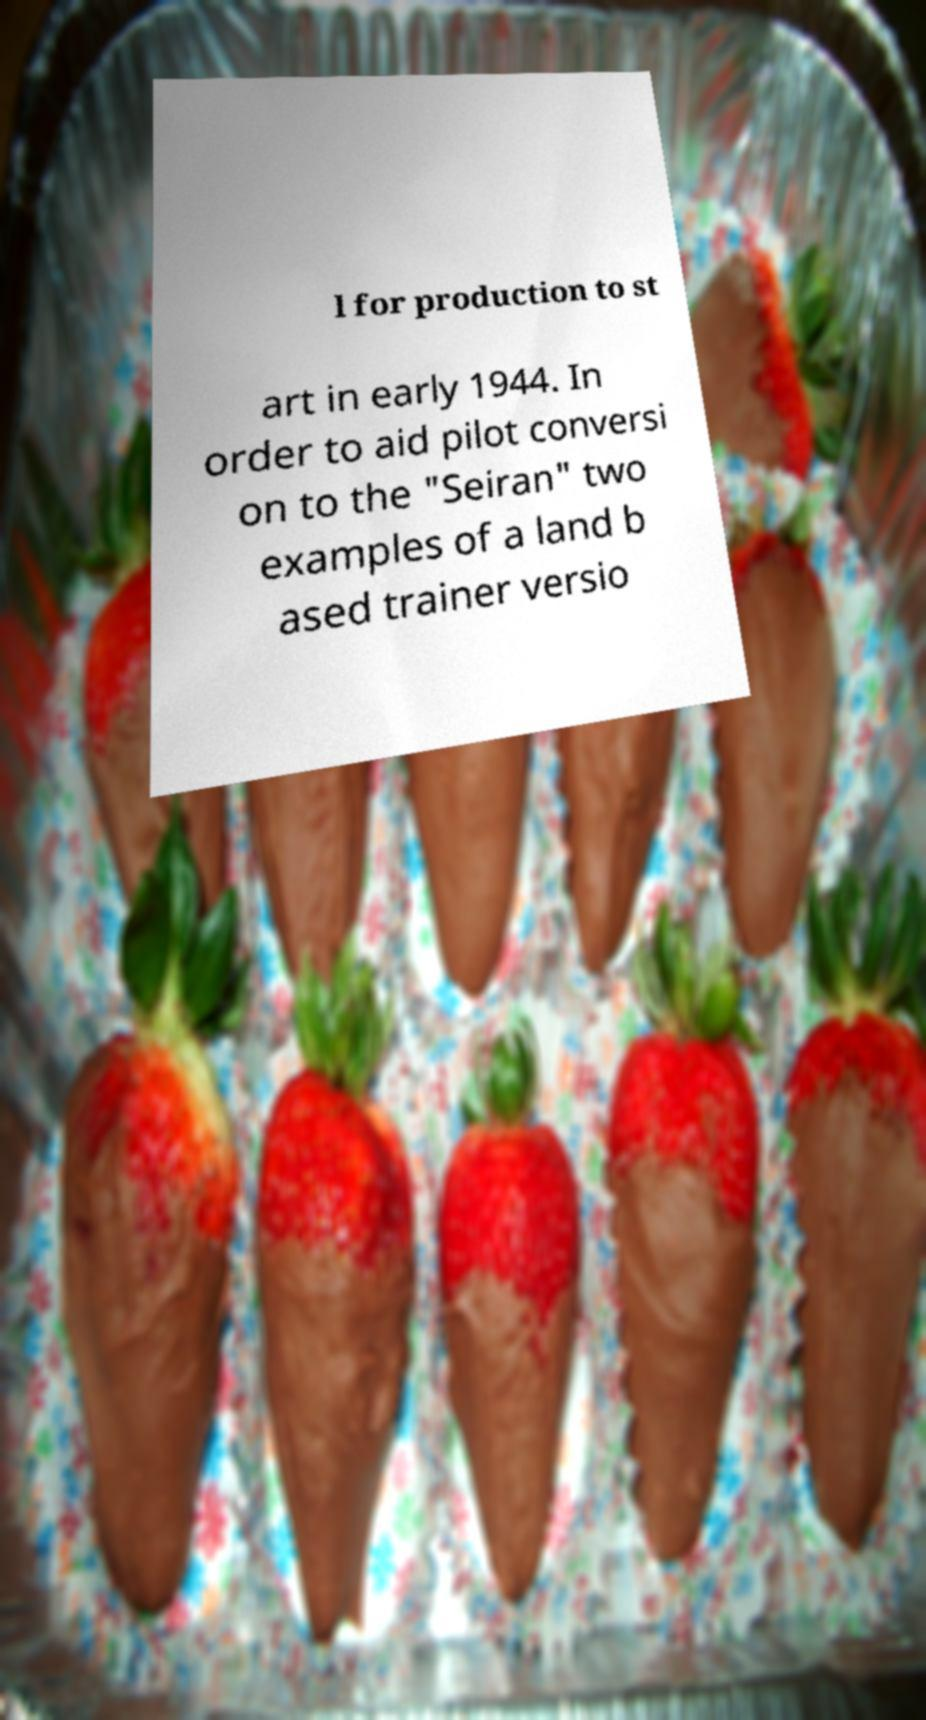For documentation purposes, I need the text within this image transcribed. Could you provide that? l for production to st art in early 1944. In order to aid pilot conversi on to the "Seiran" two examples of a land b ased trainer versio 